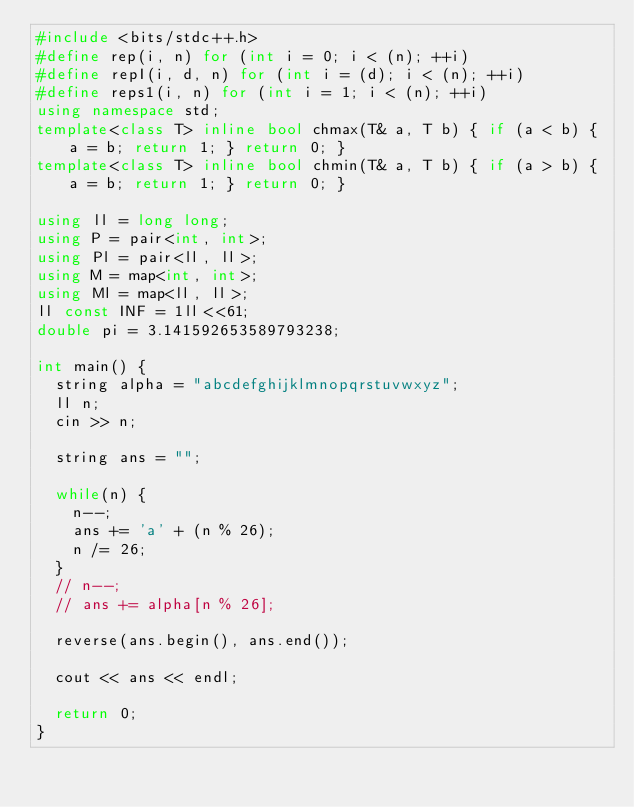<code> <loc_0><loc_0><loc_500><loc_500><_C++_>#include <bits/stdc++.h>
#define rep(i, n) for (int i = 0; i < (n); ++i)
#define repI(i, d, n) for (int i = (d); i < (n); ++i)
#define reps1(i, n) for (int i = 1; i < (n); ++i)
using namespace std;
template<class T> inline bool chmax(T& a, T b) { if (a < b) { a = b; return 1; } return 0; }
template<class T> inline bool chmin(T& a, T b) { if (a > b) { a = b; return 1; } return 0; }

using ll = long long;
using P = pair<int, int>;
using Pl = pair<ll, ll>;
using M = map<int, int>;
using Ml = map<ll, ll>;
ll const INF = 1ll<<61;
double pi = 3.141592653589793238;

int main() {
  string alpha = "abcdefghijklmnopqrstuvwxyz";
  ll n;
  cin >> n;

  string ans = "";

  while(n) {
    n--;
    ans += 'a' + (n % 26);
    n /= 26;
  }
  // n--;
  // ans += alpha[n % 26];

  reverse(ans.begin(), ans.end());

  cout << ans << endl;

  return 0;
}
</code> 